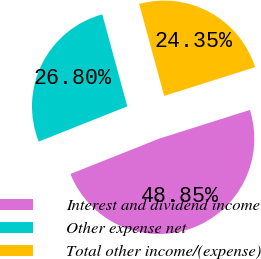Convert chart to OTSL. <chart><loc_0><loc_0><loc_500><loc_500><pie_chart><fcel>Interest and dividend income<fcel>Other expense net<fcel>Total other income/(expense)<nl><fcel>48.85%<fcel>26.8%<fcel>24.35%<nl></chart> 